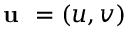<formula> <loc_0><loc_0><loc_500><loc_500>u = ( u , v )</formula> 